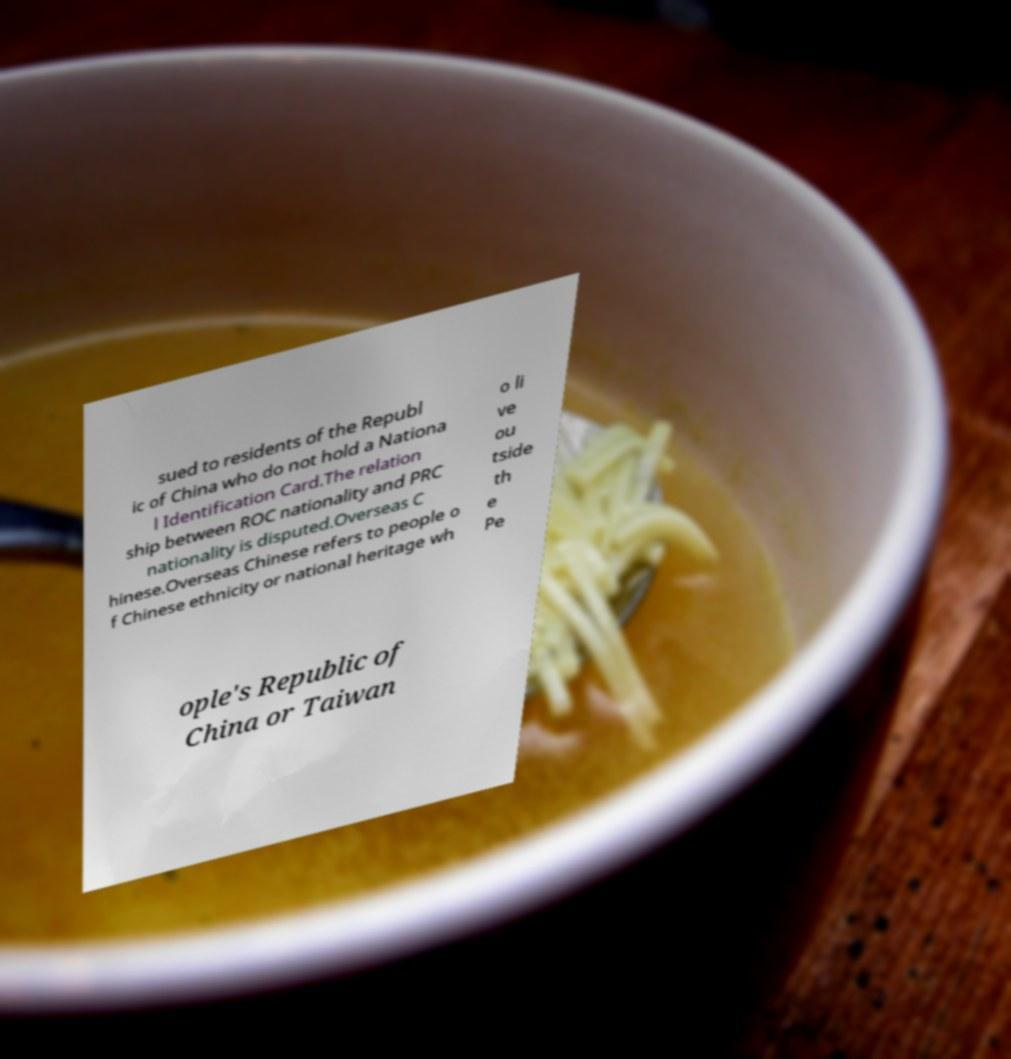For documentation purposes, I need the text within this image transcribed. Could you provide that? sued to residents of the Republ ic of China who do not hold a Nationa l Identification Card.The relation ship between ROC nationality and PRC nationality is disputed.Overseas C hinese.Overseas Chinese refers to people o f Chinese ethnicity or national heritage wh o li ve ou tside th e Pe ople's Republic of China or Taiwan 